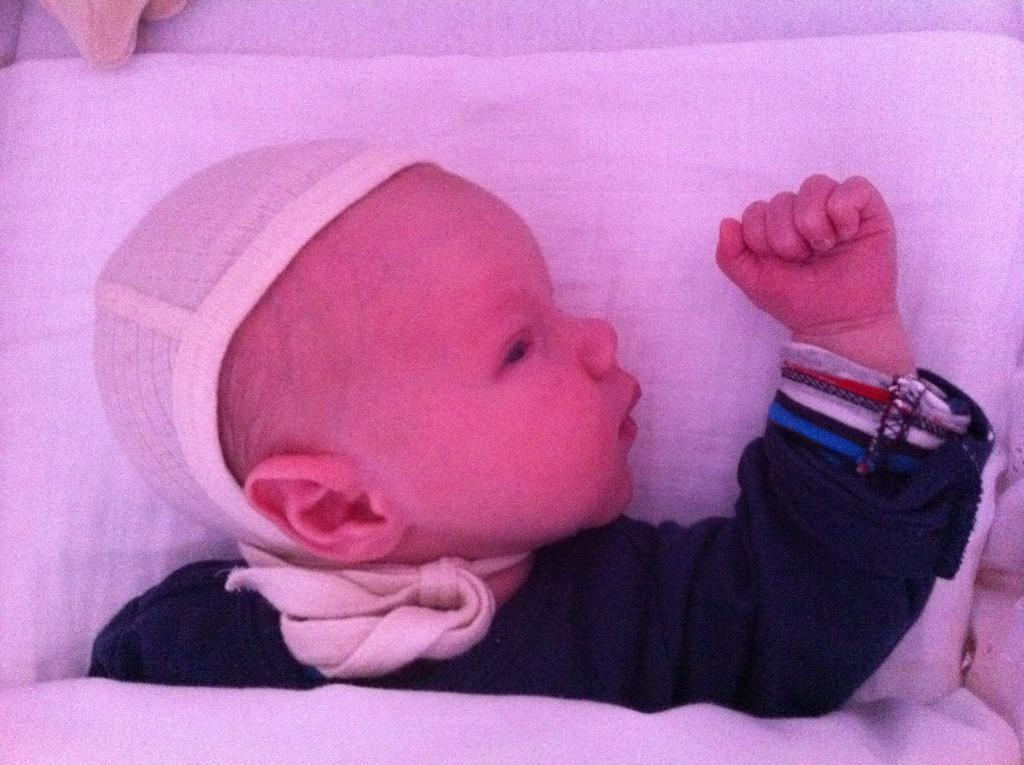What is the main subject of the image? The main subject of the image is an infant. Where is the infant located in the image? The infant is on a bed in the image. What is covering the infant's head? There is a cloth around the infant's head in the image. What riddle does the infant solve in the image? There is no riddle present in the image; it features an infant on a bed with a cloth around their head. 